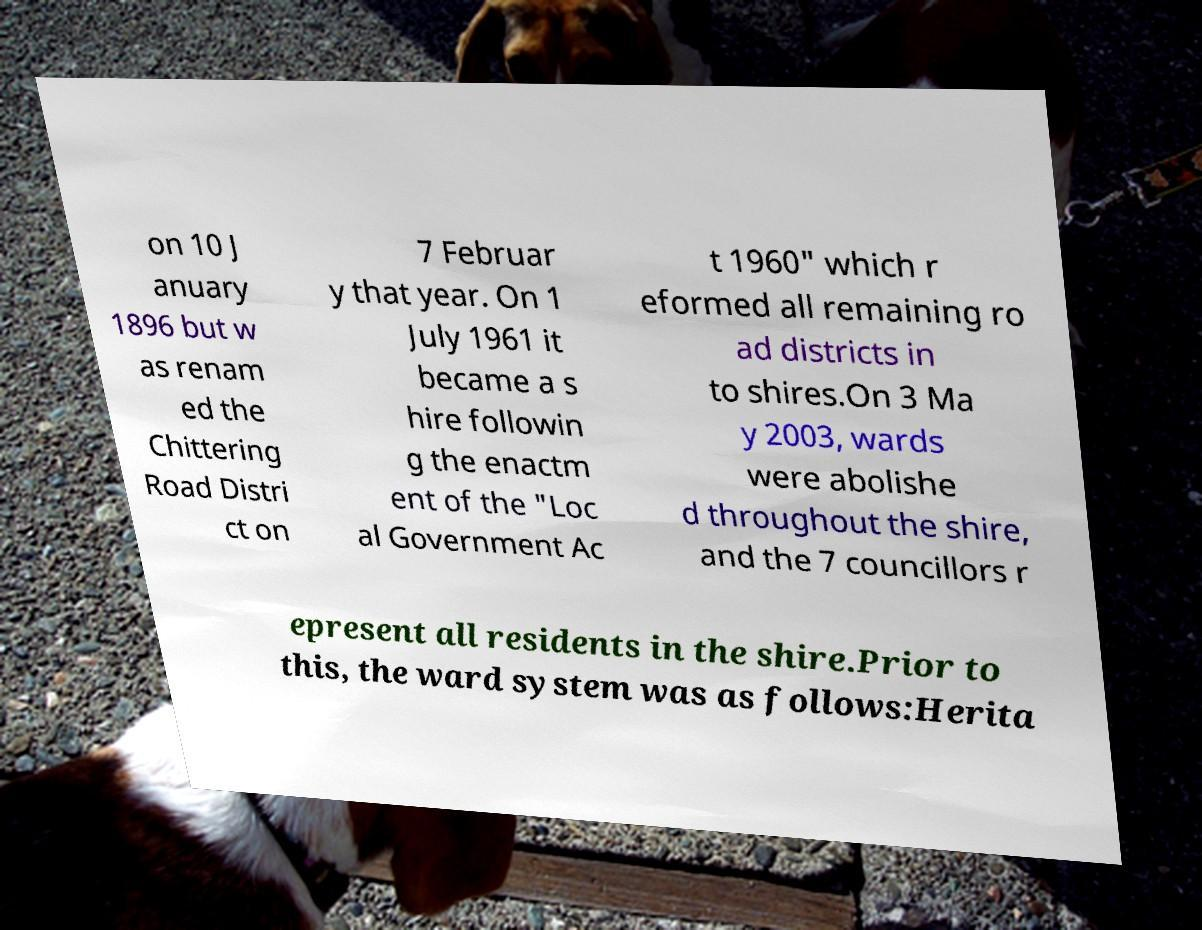Please read and relay the text visible in this image. What does it say? on 10 J anuary 1896 but w as renam ed the Chittering Road Distri ct on 7 Februar y that year. On 1 July 1961 it became a s hire followin g the enactm ent of the "Loc al Government Ac t 1960" which r eformed all remaining ro ad districts in to shires.On 3 Ma y 2003, wards were abolishe d throughout the shire, and the 7 councillors r epresent all residents in the shire.Prior to this, the ward system was as follows:Herita 